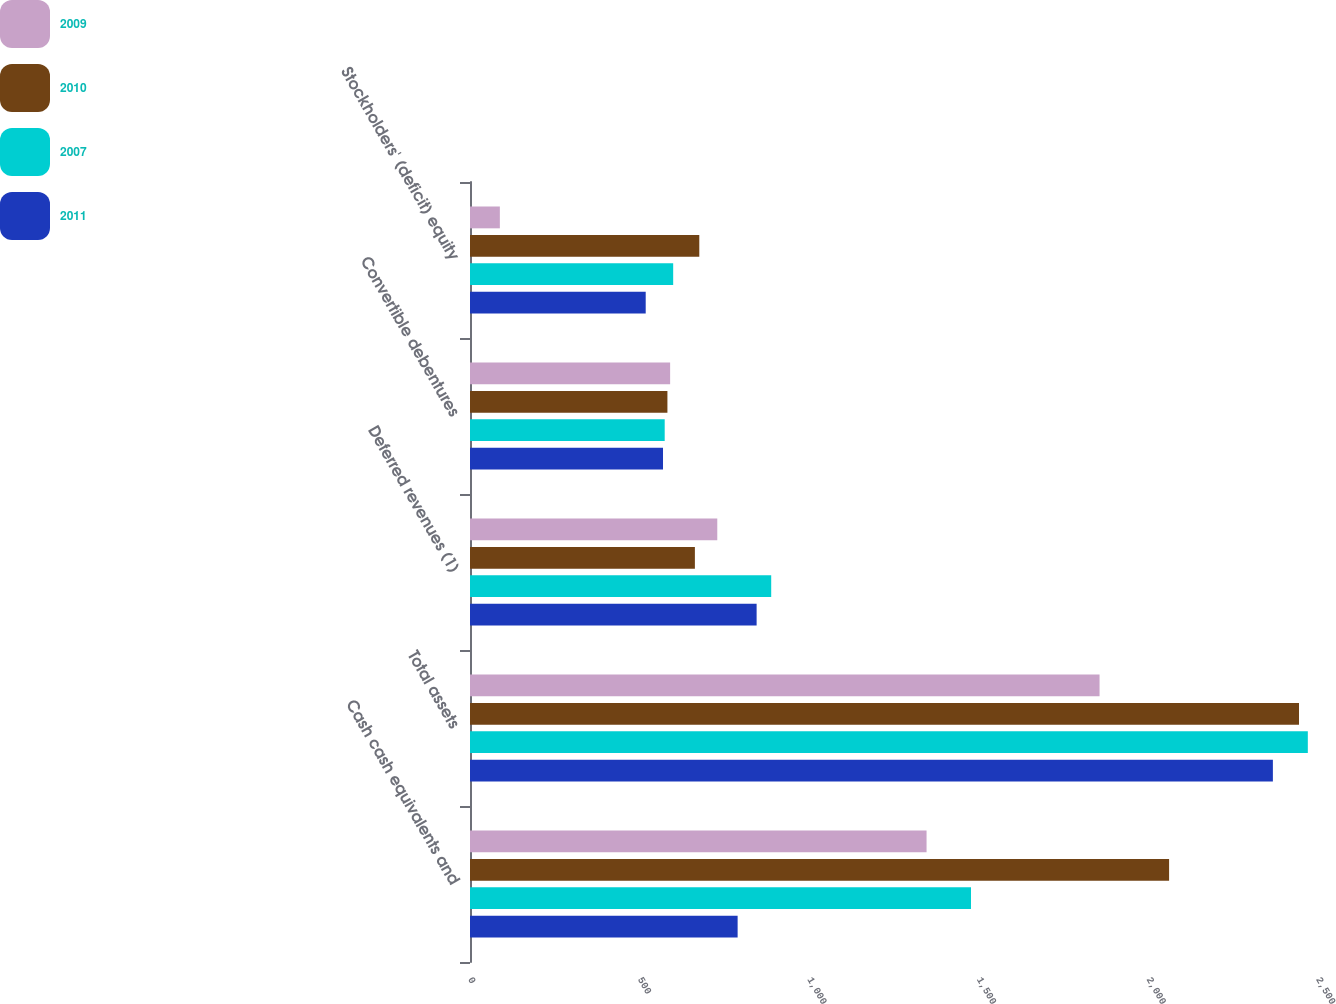<chart> <loc_0><loc_0><loc_500><loc_500><stacked_bar_chart><ecel><fcel>Cash cash equivalents and<fcel>Total assets<fcel>Deferred revenues (1)<fcel>Convertible debentures<fcel>Stockholders' (deficit) equity<nl><fcel>2009<fcel>1346<fcel>1856<fcel>729<fcel>590<fcel>88<nl><fcel>2010<fcel>2061<fcel>2444<fcel>663<fcel>582<fcel>676<nl><fcel>2007<fcel>1477<fcel>2470<fcel>888<fcel>574<fcel>599<nl><fcel>2011<fcel>789<fcel>2367<fcel>845<fcel>569<fcel>518<nl></chart> 